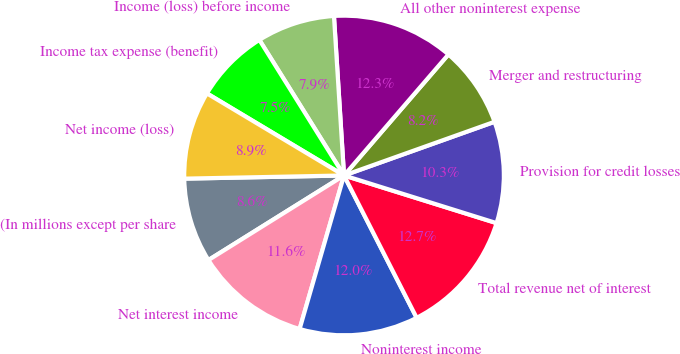Convert chart to OTSL. <chart><loc_0><loc_0><loc_500><loc_500><pie_chart><fcel>(In millions except per share<fcel>Net interest income<fcel>Noninterest income<fcel>Total revenue net of interest<fcel>Provision for credit losses<fcel>Merger and restructuring<fcel>All other noninterest expense<fcel>Income (loss) before income<fcel>Income tax expense (benefit)<fcel>Net income (loss)<nl><fcel>8.56%<fcel>11.64%<fcel>11.99%<fcel>12.67%<fcel>10.27%<fcel>8.22%<fcel>12.33%<fcel>7.88%<fcel>7.53%<fcel>8.9%<nl></chart> 